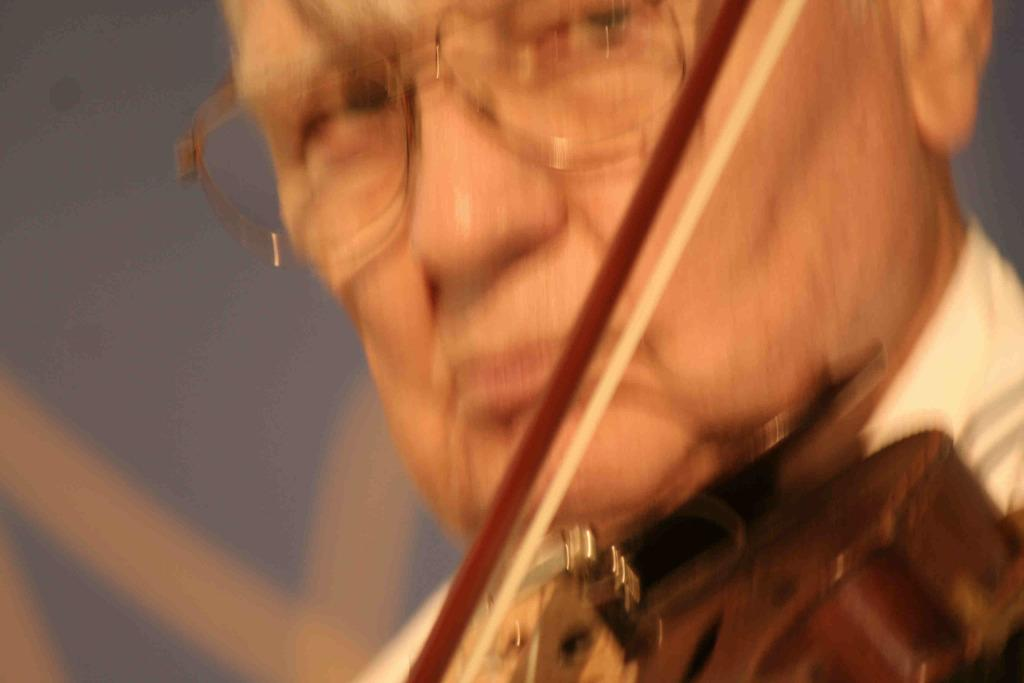What is the main subject of the image? There is a person in the image. What is the person doing in the image? The person is playing the guitar. Can you describe any accessories the person is wearing? The person is wearing glasses. How many cent systems are visible in the image? There are no cent systems present in the image. Is there a train visible in the image? There is no train present in the image. 